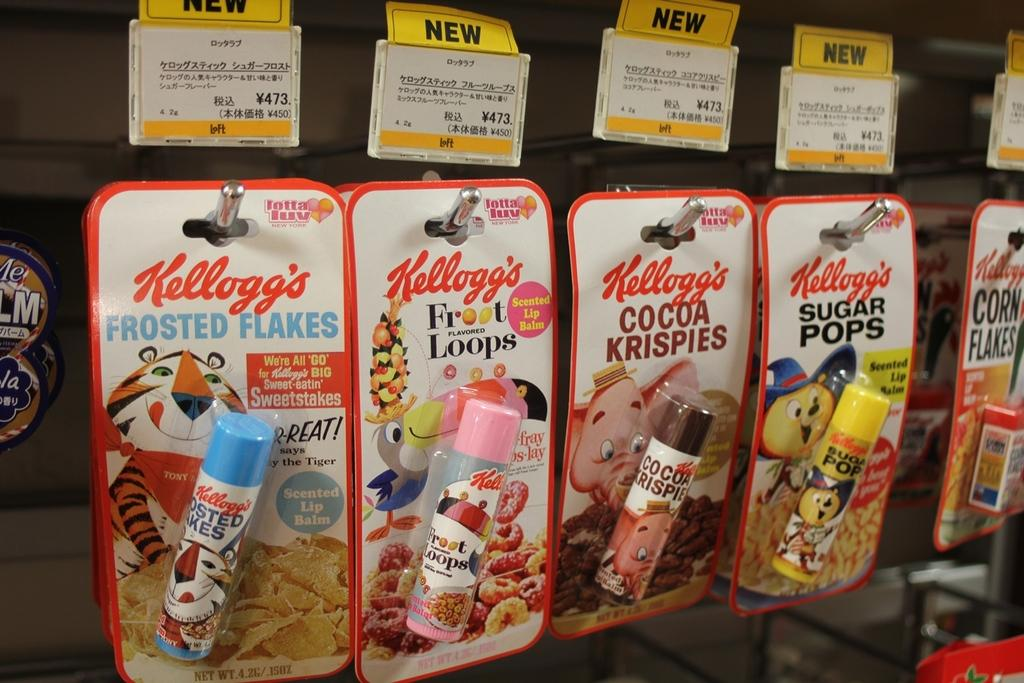What type of product is featured in the image? There are Kellogg's lip balms in the image. How are the lip balms presented in the image? The lip balms are on display. What level of society is depicted in the image? The image does not depict any specific level of society; it features Kellogg's lip balms on display. How does the neck of the person in the image look? There is no person present in the image, only Kellogg's lip balms on display. 